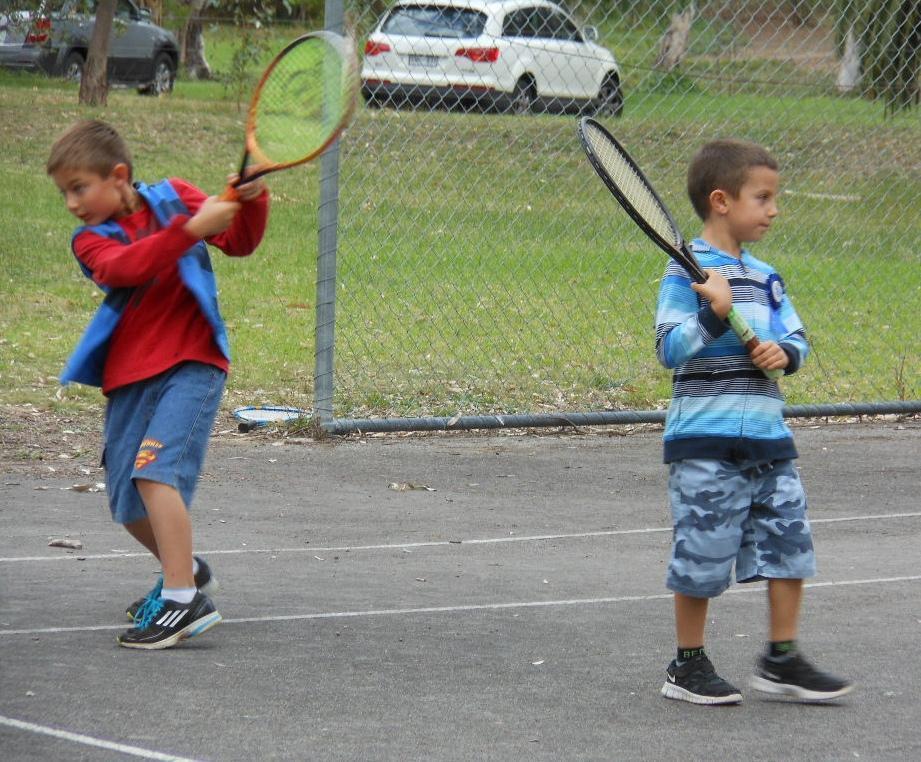How many boys are playing?
Give a very brief answer. 2. 